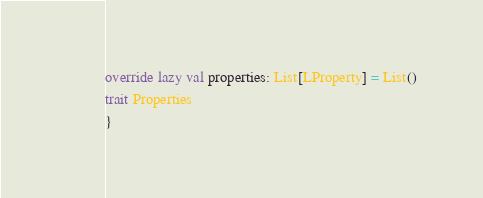Convert code to text. <code><loc_0><loc_0><loc_500><loc_500><_Scala_>
override lazy val properties: List[LProperty] = List()
trait Properties 
}</code> 